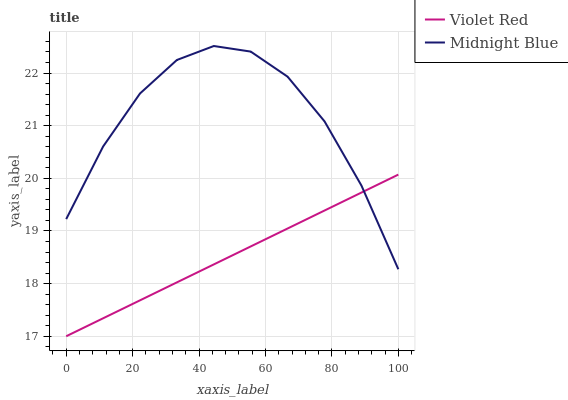Does Violet Red have the minimum area under the curve?
Answer yes or no. Yes. Does Midnight Blue have the maximum area under the curve?
Answer yes or no. Yes. Does Midnight Blue have the minimum area under the curve?
Answer yes or no. No. Is Violet Red the smoothest?
Answer yes or no. Yes. Is Midnight Blue the roughest?
Answer yes or no. Yes. Is Midnight Blue the smoothest?
Answer yes or no. No. Does Midnight Blue have the lowest value?
Answer yes or no. No. 